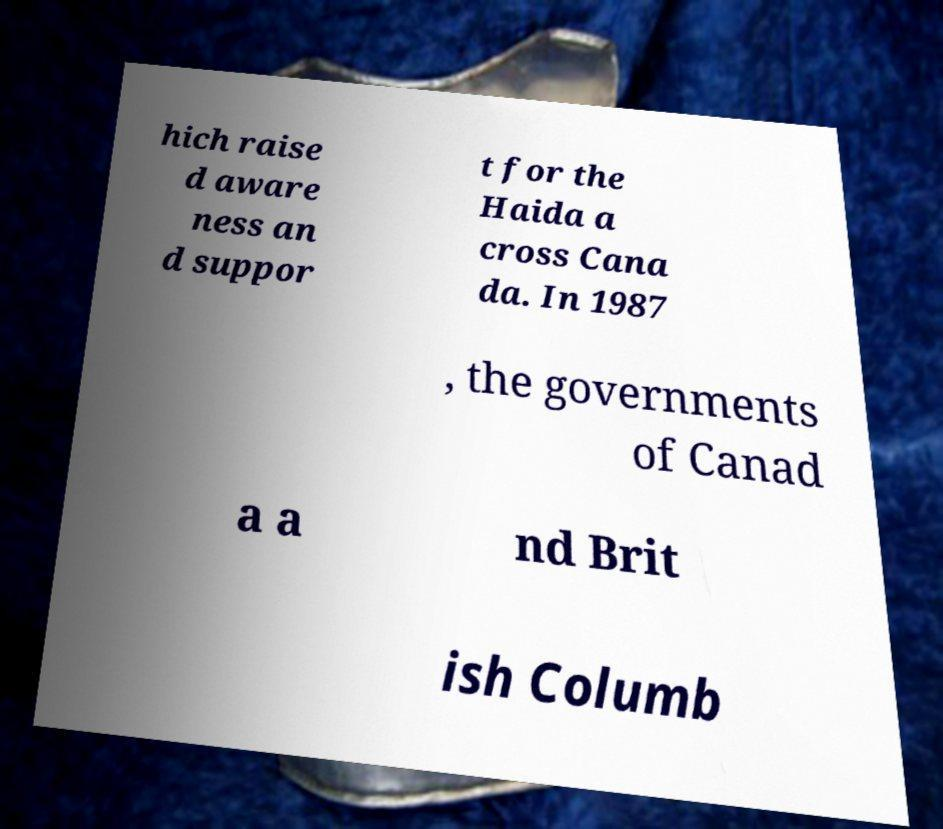Could you extract and type out the text from this image? hich raise d aware ness an d suppor t for the Haida a cross Cana da. In 1987 , the governments of Canad a a nd Brit ish Columb 